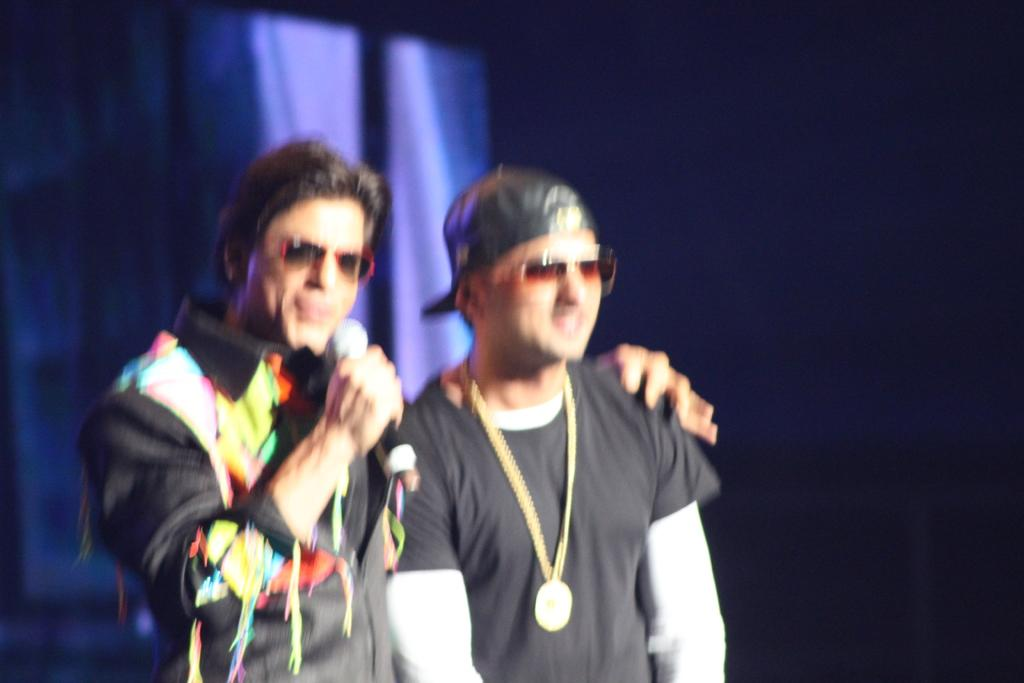How many people are in the image? There are two men in the image. What are the men wearing? Both men are wearing black color dress. Where are the men located in the image? The men are standing on a stage. What accessory are the men wearing? The men are wearing glasses. What can be observed about the background of the image? The background of the image has a dark view. What type of steam is coming out of the earth in the image? There is no steam or earth present in the image; it features two men standing on a stage. What day of the week is depicted in the image? The image does not depict a specific day of the week; it only shows two men on a stage. 